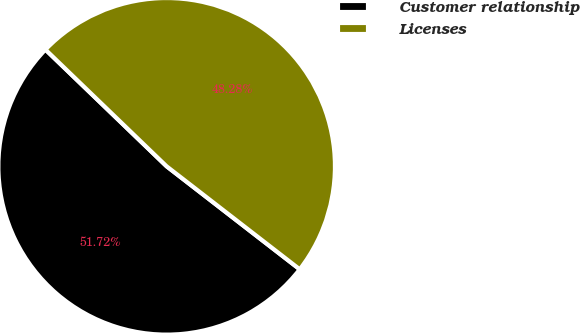Convert chart to OTSL. <chart><loc_0><loc_0><loc_500><loc_500><pie_chart><fcel>Customer relationship<fcel>Licenses<nl><fcel>51.72%<fcel>48.28%<nl></chart> 